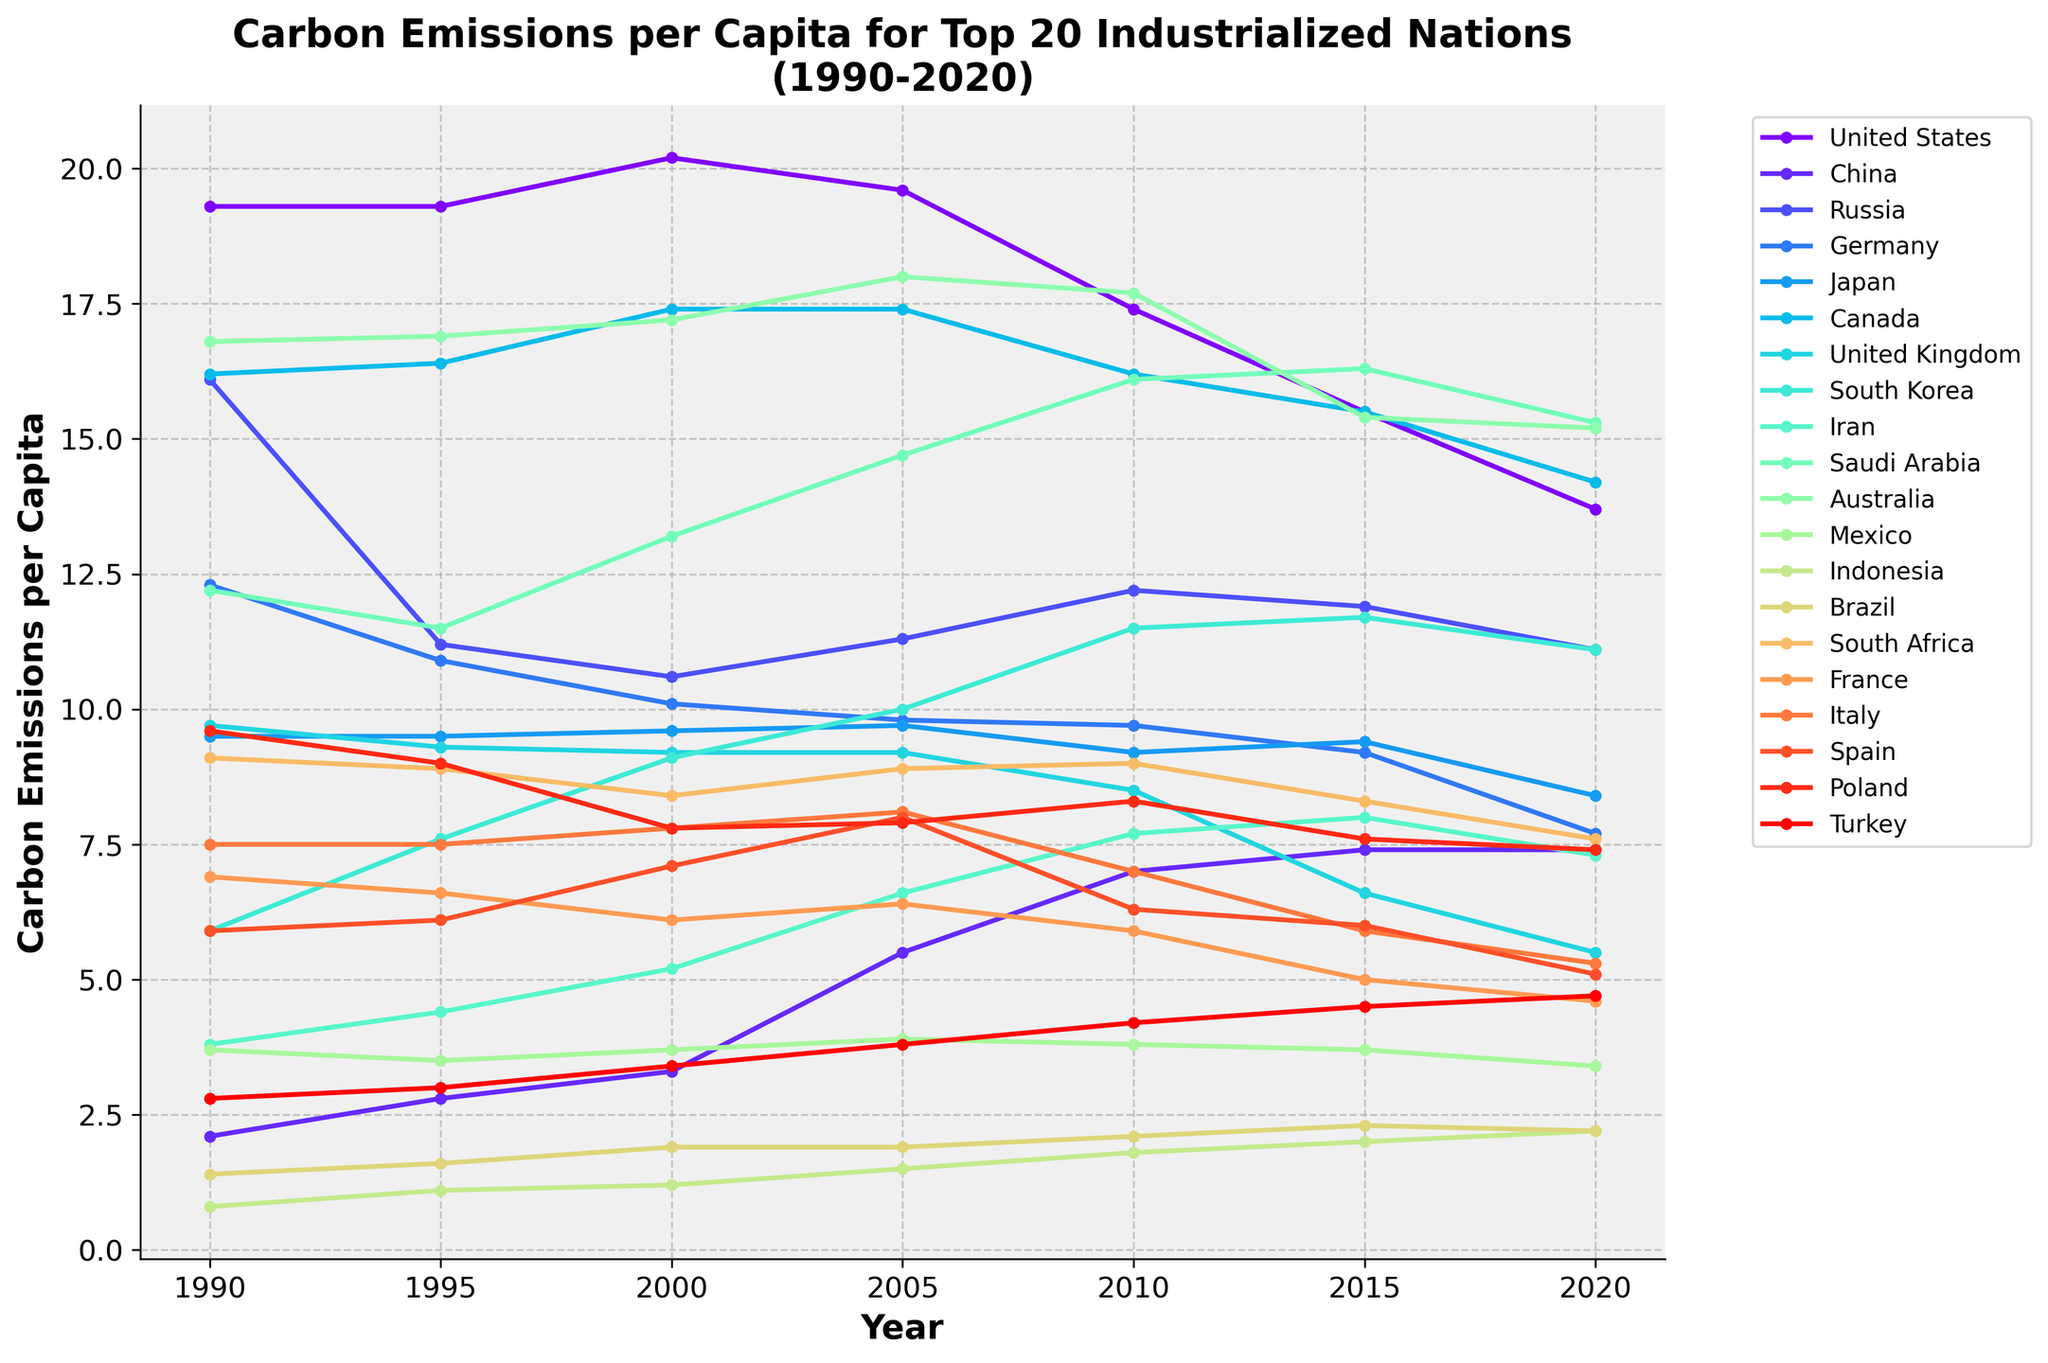What was the carbon emissions per capita for the United States in 2020? Check the value where the 'United States' line corresponds to 2020 on the x-axis.
Answer: 13.7 From 1990 to 2020, which country had the greatest increase in carbon emissions per capita? Calculate the difference between the values for 2020 and 1990 for each country. The country with the highest positive difference had the greatest increase.
Answer: China In 1990, which two countries had the highest and lowest carbon emissions per capita? Identify the maximum and minimum values from the 1990 data points.
Answer: Australia (16.8), Indonesia (0.8) Compare carbon emissions per capita between Germany and South Korea in 2010. Which country had higher emissions? Check the values where the 'Germany' and 'South Korea' lines correspond to 2010 on the x-axis and compare them.
Answer: South Korea What's the trend of carbon emissions per capita for Japan from 1990 to 2020? Observe the path of the 'Japan' line across the timeline from 1990 to 2020.
Answer: Slight decrease Which countries had a consistent decrease in carbon emissions per capita from 1990 to 2020? Identify the lines that show a consistent downward trend throughout the period.
Answer: United States, Germany, United Kingdom, Russia, France, Spain, Italy Did any country have higher carbon emissions per capita than the United States in 1990? Find values higher than the United States' 1990 value (19.3) on the y-axis.
Answer: No What is the average carbon emissions per capita for Canada across all the years presented? Sum the values for 'Canada' across all the years and divide by the number of years. (16.2 + 16.4 + 17.4 + 17.4 + 16.2 + 15.5 + 14.2)/7 ≈ 16.2.
Answer: 16.2 How did Poland's carbon emissions per capita change from 1990 to 2020? Subtract the 1990 value for Poland from the 2020 value for Poland. 7.4 - 9.6 = -2.2
Answer: Decrease by 2.2 Which country had a peak in carbon emissions per capita in 2005 and then a decline by 2020? Examine each line to identify the highest value in 2005 that subsequently decreases by 2020.
Answer: Saudi Arabia 